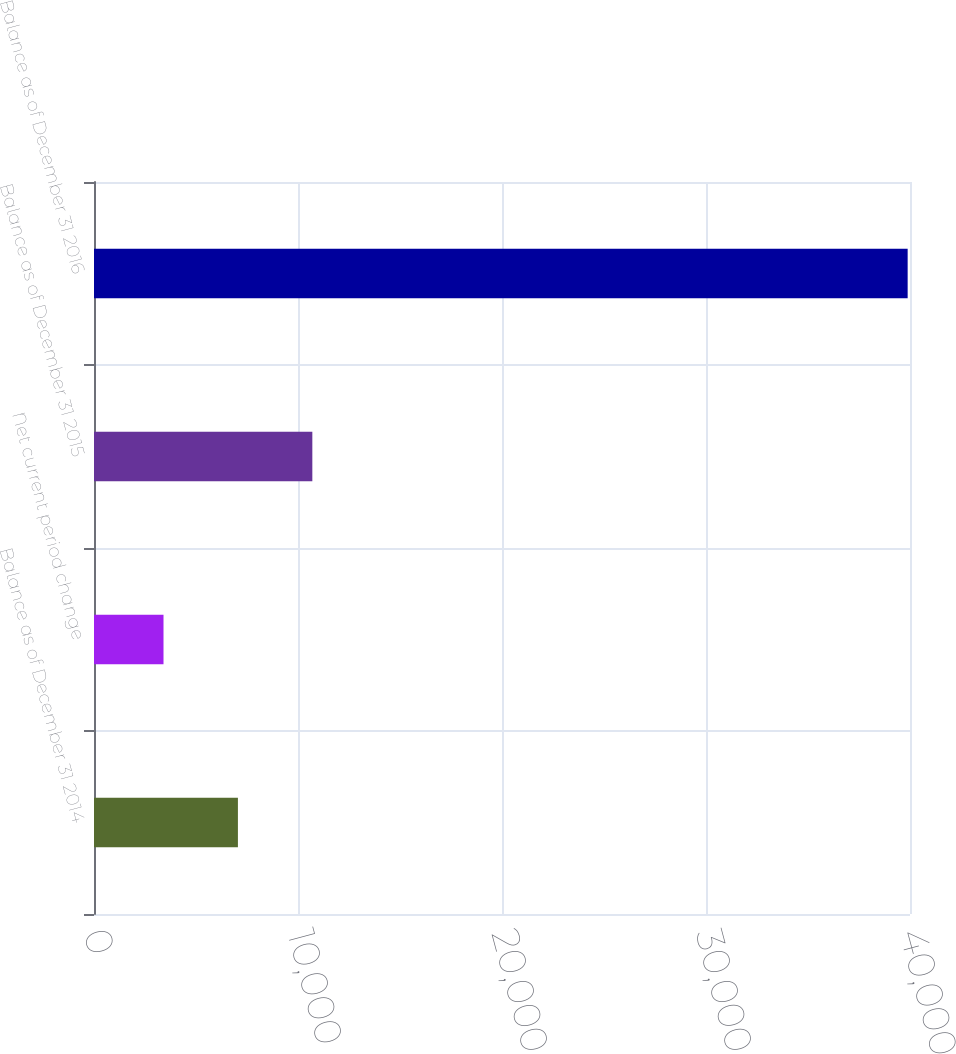Convert chart to OTSL. <chart><loc_0><loc_0><loc_500><loc_500><bar_chart><fcel>Balance as of December 31 2014<fcel>Net current period change<fcel>Balance as of December 31 2015<fcel>Balance as of December 31 2016<nl><fcel>7054.8<fcel>3407<fcel>10702.6<fcel>39885<nl></chart> 